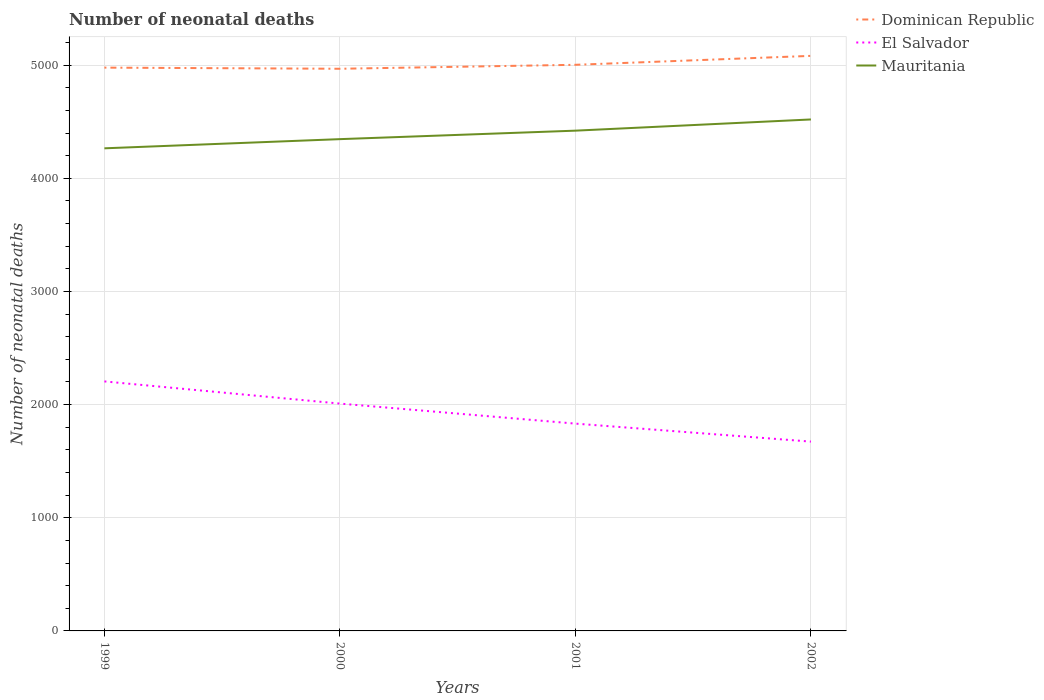How many different coloured lines are there?
Give a very brief answer. 3. Is the number of lines equal to the number of legend labels?
Your answer should be very brief. Yes. Across all years, what is the maximum number of neonatal deaths in in Dominican Republic?
Ensure brevity in your answer.  4968. What is the total number of neonatal deaths in in El Salvador in the graph?
Your answer should be compact. 196. What is the difference between the highest and the second highest number of neonatal deaths in in Mauritania?
Your response must be concise. 255. What is the difference between the highest and the lowest number of neonatal deaths in in El Salvador?
Provide a succinct answer. 2. How many lines are there?
Offer a very short reply. 3. How many years are there in the graph?
Your response must be concise. 4. What is the difference between two consecutive major ticks on the Y-axis?
Your answer should be compact. 1000. Are the values on the major ticks of Y-axis written in scientific E-notation?
Make the answer very short. No. Does the graph contain any zero values?
Your answer should be compact. No. What is the title of the graph?
Your response must be concise. Number of neonatal deaths. What is the label or title of the Y-axis?
Provide a short and direct response. Number of neonatal deaths. What is the Number of neonatal deaths in Dominican Republic in 1999?
Your answer should be compact. 4978. What is the Number of neonatal deaths of El Salvador in 1999?
Provide a succinct answer. 2205. What is the Number of neonatal deaths of Mauritania in 1999?
Your response must be concise. 4265. What is the Number of neonatal deaths of Dominican Republic in 2000?
Offer a very short reply. 4968. What is the Number of neonatal deaths of El Salvador in 2000?
Offer a very short reply. 2009. What is the Number of neonatal deaths in Mauritania in 2000?
Keep it short and to the point. 4346. What is the Number of neonatal deaths of Dominican Republic in 2001?
Your answer should be compact. 5003. What is the Number of neonatal deaths in El Salvador in 2001?
Provide a succinct answer. 1832. What is the Number of neonatal deaths of Mauritania in 2001?
Your answer should be very brief. 4421. What is the Number of neonatal deaths of Dominican Republic in 2002?
Your response must be concise. 5082. What is the Number of neonatal deaths of El Salvador in 2002?
Keep it short and to the point. 1673. What is the Number of neonatal deaths in Mauritania in 2002?
Provide a short and direct response. 4520. Across all years, what is the maximum Number of neonatal deaths of Dominican Republic?
Your response must be concise. 5082. Across all years, what is the maximum Number of neonatal deaths of El Salvador?
Provide a short and direct response. 2205. Across all years, what is the maximum Number of neonatal deaths of Mauritania?
Offer a terse response. 4520. Across all years, what is the minimum Number of neonatal deaths of Dominican Republic?
Your answer should be very brief. 4968. Across all years, what is the minimum Number of neonatal deaths in El Salvador?
Offer a terse response. 1673. Across all years, what is the minimum Number of neonatal deaths in Mauritania?
Your answer should be compact. 4265. What is the total Number of neonatal deaths of Dominican Republic in the graph?
Your answer should be compact. 2.00e+04. What is the total Number of neonatal deaths of El Salvador in the graph?
Provide a succinct answer. 7719. What is the total Number of neonatal deaths in Mauritania in the graph?
Give a very brief answer. 1.76e+04. What is the difference between the Number of neonatal deaths of El Salvador in 1999 and that in 2000?
Your answer should be very brief. 196. What is the difference between the Number of neonatal deaths in Mauritania in 1999 and that in 2000?
Give a very brief answer. -81. What is the difference between the Number of neonatal deaths of Dominican Republic in 1999 and that in 2001?
Your answer should be very brief. -25. What is the difference between the Number of neonatal deaths of El Salvador in 1999 and that in 2001?
Offer a very short reply. 373. What is the difference between the Number of neonatal deaths in Mauritania in 1999 and that in 2001?
Your answer should be very brief. -156. What is the difference between the Number of neonatal deaths in Dominican Republic in 1999 and that in 2002?
Provide a succinct answer. -104. What is the difference between the Number of neonatal deaths in El Salvador in 1999 and that in 2002?
Give a very brief answer. 532. What is the difference between the Number of neonatal deaths of Mauritania in 1999 and that in 2002?
Provide a succinct answer. -255. What is the difference between the Number of neonatal deaths of Dominican Republic in 2000 and that in 2001?
Make the answer very short. -35. What is the difference between the Number of neonatal deaths in El Salvador in 2000 and that in 2001?
Your answer should be very brief. 177. What is the difference between the Number of neonatal deaths of Mauritania in 2000 and that in 2001?
Offer a terse response. -75. What is the difference between the Number of neonatal deaths of Dominican Republic in 2000 and that in 2002?
Your answer should be compact. -114. What is the difference between the Number of neonatal deaths of El Salvador in 2000 and that in 2002?
Make the answer very short. 336. What is the difference between the Number of neonatal deaths in Mauritania in 2000 and that in 2002?
Your answer should be compact. -174. What is the difference between the Number of neonatal deaths of Dominican Republic in 2001 and that in 2002?
Make the answer very short. -79. What is the difference between the Number of neonatal deaths in El Salvador in 2001 and that in 2002?
Provide a succinct answer. 159. What is the difference between the Number of neonatal deaths of Mauritania in 2001 and that in 2002?
Keep it short and to the point. -99. What is the difference between the Number of neonatal deaths in Dominican Republic in 1999 and the Number of neonatal deaths in El Salvador in 2000?
Provide a succinct answer. 2969. What is the difference between the Number of neonatal deaths of Dominican Republic in 1999 and the Number of neonatal deaths of Mauritania in 2000?
Provide a short and direct response. 632. What is the difference between the Number of neonatal deaths in El Salvador in 1999 and the Number of neonatal deaths in Mauritania in 2000?
Provide a short and direct response. -2141. What is the difference between the Number of neonatal deaths of Dominican Republic in 1999 and the Number of neonatal deaths of El Salvador in 2001?
Ensure brevity in your answer.  3146. What is the difference between the Number of neonatal deaths of Dominican Republic in 1999 and the Number of neonatal deaths of Mauritania in 2001?
Give a very brief answer. 557. What is the difference between the Number of neonatal deaths of El Salvador in 1999 and the Number of neonatal deaths of Mauritania in 2001?
Keep it short and to the point. -2216. What is the difference between the Number of neonatal deaths in Dominican Republic in 1999 and the Number of neonatal deaths in El Salvador in 2002?
Keep it short and to the point. 3305. What is the difference between the Number of neonatal deaths of Dominican Republic in 1999 and the Number of neonatal deaths of Mauritania in 2002?
Provide a succinct answer. 458. What is the difference between the Number of neonatal deaths of El Salvador in 1999 and the Number of neonatal deaths of Mauritania in 2002?
Your answer should be compact. -2315. What is the difference between the Number of neonatal deaths in Dominican Republic in 2000 and the Number of neonatal deaths in El Salvador in 2001?
Provide a short and direct response. 3136. What is the difference between the Number of neonatal deaths of Dominican Republic in 2000 and the Number of neonatal deaths of Mauritania in 2001?
Ensure brevity in your answer.  547. What is the difference between the Number of neonatal deaths of El Salvador in 2000 and the Number of neonatal deaths of Mauritania in 2001?
Your answer should be very brief. -2412. What is the difference between the Number of neonatal deaths of Dominican Republic in 2000 and the Number of neonatal deaths of El Salvador in 2002?
Provide a succinct answer. 3295. What is the difference between the Number of neonatal deaths in Dominican Republic in 2000 and the Number of neonatal deaths in Mauritania in 2002?
Your answer should be compact. 448. What is the difference between the Number of neonatal deaths of El Salvador in 2000 and the Number of neonatal deaths of Mauritania in 2002?
Provide a succinct answer. -2511. What is the difference between the Number of neonatal deaths in Dominican Republic in 2001 and the Number of neonatal deaths in El Salvador in 2002?
Your response must be concise. 3330. What is the difference between the Number of neonatal deaths of Dominican Republic in 2001 and the Number of neonatal deaths of Mauritania in 2002?
Make the answer very short. 483. What is the difference between the Number of neonatal deaths in El Salvador in 2001 and the Number of neonatal deaths in Mauritania in 2002?
Offer a very short reply. -2688. What is the average Number of neonatal deaths of Dominican Republic per year?
Your response must be concise. 5007.75. What is the average Number of neonatal deaths in El Salvador per year?
Your answer should be compact. 1929.75. What is the average Number of neonatal deaths in Mauritania per year?
Your response must be concise. 4388. In the year 1999, what is the difference between the Number of neonatal deaths of Dominican Republic and Number of neonatal deaths of El Salvador?
Offer a terse response. 2773. In the year 1999, what is the difference between the Number of neonatal deaths of Dominican Republic and Number of neonatal deaths of Mauritania?
Your response must be concise. 713. In the year 1999, what is the difference between the Number of neonatal deaths in El Salvador and Number of neonatal deaths in Mauritania?
Give a very brief answer. -2060. In the year 2000, what is the difference between the Number of neonatal deaths of Dominican Republic and Number of neonatal deaths of El Salvador?
Your response must be concise. 2959. In the year 2000, what is the difference between the Number of neonatal deaths in Dominican Republic and Number of neonatal deaths in Mauritania?
Your answer should be very brief. 622. In the year 2000, what is the difference between the Number of neonatal deaths in El Salvador and Number of neonatal deaths in Mauritania?
Offer a very short reply. -2337. In the year 2001, what is the difference between the Number of neonatal deaths of Dominican Republic and Number of neonatal deaths of El Salvador?
Make the answer very short. 3171. In the year 2001, what is the difference between the Number of neonatal deaths of Dominican Republic and Number of neonatal deaths of Mauritania?
Provide a succinct answer. 582. In the year 2001, what is the difference between the Number of neonatal deaths in El Salvador and Number of neonatal deaths in Mauritania?
Provide a succinct answer. -2589. In the year 2002, what is the difference between the Number of neonatal deaths of Dominican Republic and Number of neonatal deaths of El Salvador?
Provide a short and direct response. 3409. In the year 2002, what is the difference between the Number of neonatal deaths of Dominican Republic and Number of neonatal deaths of Mauritania?
Ensure brevity in your answer.  562. In the year 2002, what is the difference between the Number of neonatal deaths in El Salvador and Number of neonatal deaths in Mauritania?
Give a very brief answer. -2847. What is the ratio of the Number of neonatal deaths in El Salvador in 1999 to that in 2000?
Give a very brief answer. 1.1. What is the ratio of the Number of neonatal deaths in Mauritania in 1999 to that in 2000?
Give a very brief answer. 0.98. What is the ratio of the Number of neonatal deaths of El Salvador in 1999 to that in 2001?
Offer a very short reply. 1.2. What is the ratio of the Number of neonatal deaths of Mauritania in 1999 to that in 2001?
Your answer should be compact. 0.96. What is the ratio of the Number of neonatal deaths in Dominican Republic in 1999 to that in 2002?
Offer a terse response. 0.98. What is the ratio of the Number of neonatal deaths of El Salvador in 1999 to that in 2002?
Provide a succinct answer. 1.32. What is the ratio of the Number of neonatal deaths in Mauritania in 1999 to that in 2002?
Your answer should be compact. 0.94. What is the ratio of the Number of neonatal deaths of Dominican Republic in 2000 to that in 2001?
Your answer should be very brief. 0.99. What is the ratio of the Number of neonatal deaths in El Salvador in 2000 to that in 2001?
Your answer should be compact. 1.1. What is the ratio of the Number of neonatal deaths in Dominican Republic in 2000 to that in 2002?
Make the answer very short. 0.98. What is the ratio of the Number of neonatal deaths in El Salvador in 2000 to that in 2002?
Ensure brevity in your answer.  1.2. What is the ratio of the Number of neonatal deaths of Mauritania in 2000 to that in 2002?
Provide a succinct answer. 0.96. What is the ratio of the Number of neonatal deaths of Dominican Republic in 2001 to that in 2002?
Offer a very short reply. 0.98. What is the ratio of the Number of neonatal deaths of El Salvador in 2001 to that in 2002?
Offer a terse response. 1.09. What is the ratio of the Number of neonatal deaths of Mauritania in 2001 to that in 2002?
Make the answer very short. 0.98. What is the difference between the highest and the second highest Number of neonatal deaths in Dominican Republic?
Make the answer very short. 79. What is the difference between the highest and the second highest Number of neonatal deaths of El Salvador?
Your answer should be compact. 196. What is the difference between the highest and the second highest Number of neonatal deaths of Mauritania?
Your answer should be very brief. 99. What is the difference between the highest and the lowest Number of neonatal deaths of Dominican Republic?
Your answer should be compact. 114. What is the difference between the highest and the lowest Number of neonatal deaths in El Salvador?
Keep it short and to the point. 532. What is the difference between the highest and the lowest Number of neonatal deaths of Mauritania?
Provide a succinct answer. 255. 